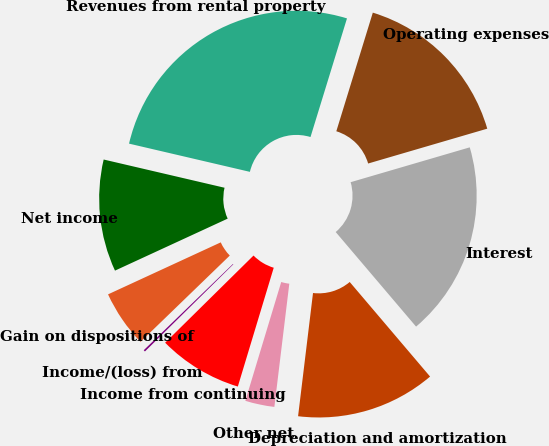Convert chart. <chart><loc_0><loc_0><loc_500><loc_500><pie_chart><fcel>Revenues from rental property<fcel>Operating expenses<fcel>Interest<fcel>Depreciation and amortization<fcel>Other net<fcel>Income from continuing<fcel>Income/(loss) from<fcel>Gain on dispositions of<fcel>Net income<nl><fcel>26.1%<fcel>15.72%<fcel>18.32%<fcel>13.13%<fcel>2.75%<fcel>7.94%<fcel>0.16%<fcel>5.35%<fcel>10.53%<nl></chart> 